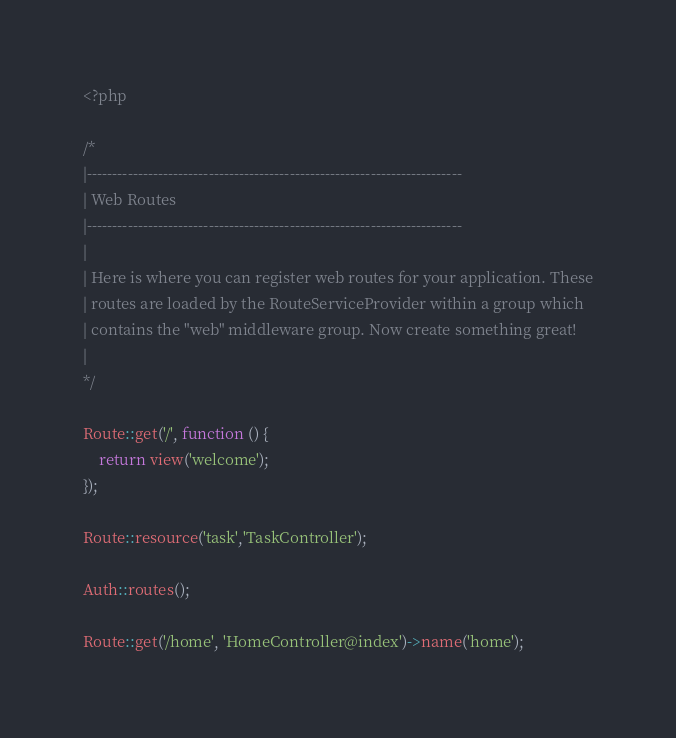<code> <loc_0><loc_0><loc_500><loc_500><_PHP_><?php

/*
|--------------------------------------------------------------------------
| Web Routes
|--------------------------------------------------------------------------
|
| Here is where you can register web routes for your application. These
| routes are loaded by the RouteServiceProvider within a group which
| contains the "web" middleware group. Now create something great!
|
*/

Route::get('/', function () {
    return view('welcome');
});

Route::resource('task','TaskController');

Auth::routes();

Route::get('/home', 'HomeController@index')->name('home');
</code> 